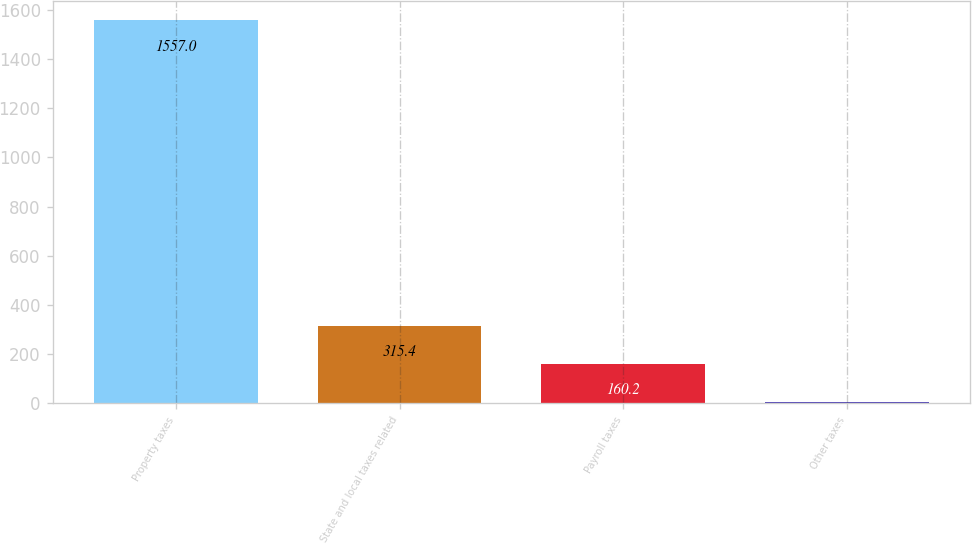Convert chart. <chart><loc_0><loc_0><loc_500><loc_500><bar_chart><fcel>Property taxes<fcel>State and local taxes related<fcel>Payroll taxes<fcel>Other taxes<nl><fcel>1557<fcel>315.4<fcel>160.2<fcel>5<nl></chart> 